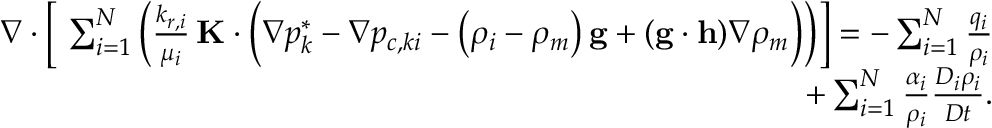Convert formula to latex. <formula><loc_0><loc_0><loc_500><loc_500>\begin{array} { r } { \nabla \cdot \left [ \ \sum _ { i = 1 } ^ { N } \left ( \frac { k _ { r , i } } { \mu _ { i } } \, K \cdot \left ( \nabla p _ { k } ^ { * } - \nabla p _ { c , k i } - \left ( \rho _ { i } - \rho _ { m } \right ) g + ( g \cdot h ) \nabla \rho _ { m } \right ) \right ) \right ] = - \sum _ { i = 1 } ^ { N } \frac { q _ { i } } { \rho _ { i } } } \\ { + \sum _ { i = 1 } ^ { N } \frac { \alpha _ { i } } { \rho _ { i } } \frac { D _ { i } \rho _ { i } } { D t } . } \end{array}</formula> 